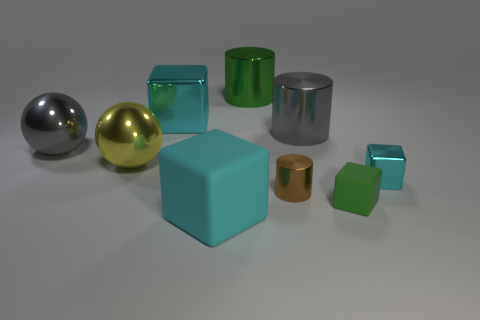Does the brown object have the same shape as the large yellow thing?
Keep it short and to the point. No. Is the gray metal cylinder the same size as the brown cylinder?
Your answer should be very brief. No. What number of tiny things are there?
Your answer should be very brief. 3. The small brown object that is the same material as the large gray sphere is what shape?
Provide a succinct answer. Cylinder. Is the color of the large shiny object right of the tiny brown object the same as the metal object left of the big yellow metal object?
Make the answer very short. Yes. Is the number of tiny cubes to the left of the tiny cyan metallic thing the same as the number of green matte blocks?
Provide a short and direct response. Yes. There is a large gray metal ball; what number of cylinders are to the left of it?
Your answer should be compact. 0. What is the size of the brown cylinder?
Provide a succinct answer. Small. What color is the large cube that is made of the same material as the small green block?
Keep it short and to the point. Cyan. How many yellow metallic spheres are the same size as the cyan matte object?
Provide a succinct answer. 1. 